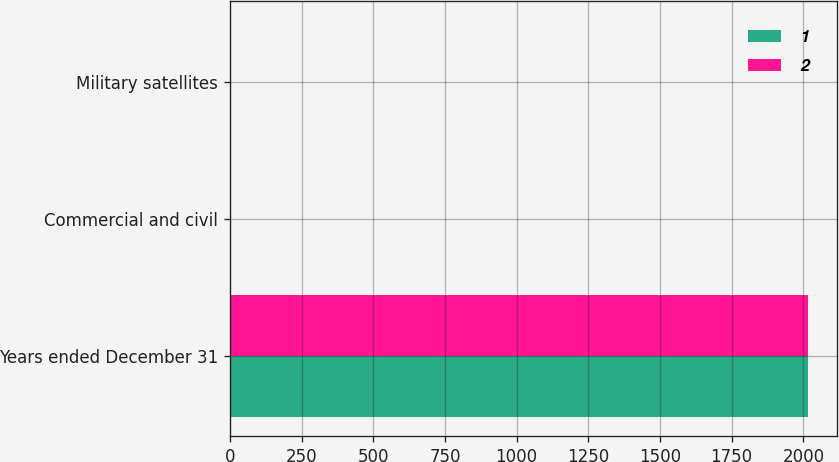<chart> <loc_0><loc_0><loc_500><loc_500><stacked_bar_chart><ecel><fcel>Years ended December 31<fcel>Commercial and civil<fcel>Military satellites<nl><fcel>1<fcel>2017<fcel>3<fcel>1<nl><fcel>2<fcel>2016<fcel>5<fcel>2<nl></chart> 